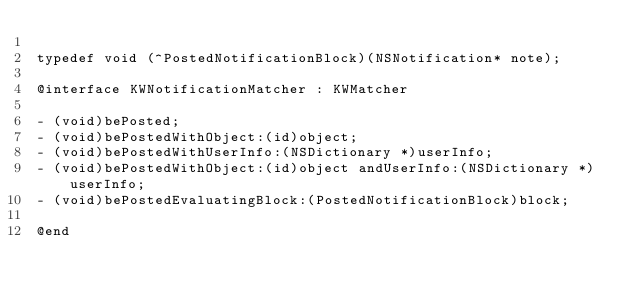<code> <loc_0><loc_0><loc_500><loc_500><_C_>
typedef void (^PostedNotificationBlock)(NSNotification* note);

@interface KWNotificationMatcher : KWMatcher

- (void)bePosted;
- (void)bePostedWithObject:(id)object;
- (void)bePostedWithUserInfo:(NSDictionary *)userInfo;
- (void)bePostedWithObject:(id)object andUserInfo:(NSDictionary *)userInfo;
- (void)bePostedEvaluatingBlock:(PostedNotificationBlock)block;

@end
</code> 